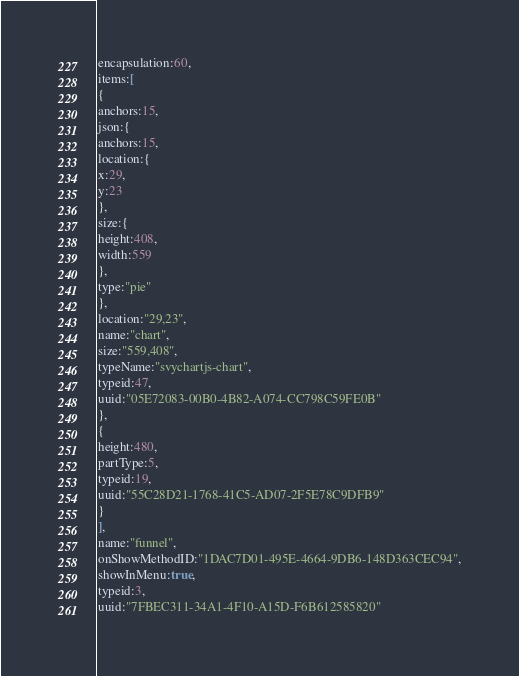Convert code to text. <code><loc_0><loc_0><loc_500><loc_500><_VisualBasic_>encapsulation:60,
items:[
{
anchors:15,
json:{
anchors:15,
location:{
x:29,
y:23
},
size:{
height:408,
width:559
},
type:"pie"
},
location:"29,23",
name:"chart",
size:"559,408",
typeName:"svychartjs-chart",
typeid:47,
uuid:"05E72083-00B0-4B82-A074-CC798C59FE0B"
},
{
height:480,
partType:5,
typeid:19,
uuid:"55C28D21-1768-41C5-AD07-2F5E78C9DFB9"
}
],
name:"funnel",
onShowMethodID:"1DAC7D01-495E-4664-9DB6-148D363CEC94",
showInMenu:true,
typeid:3,
uuid:"7FBEC311-34A1-4F10-A15D-F6B612585820"</code> 